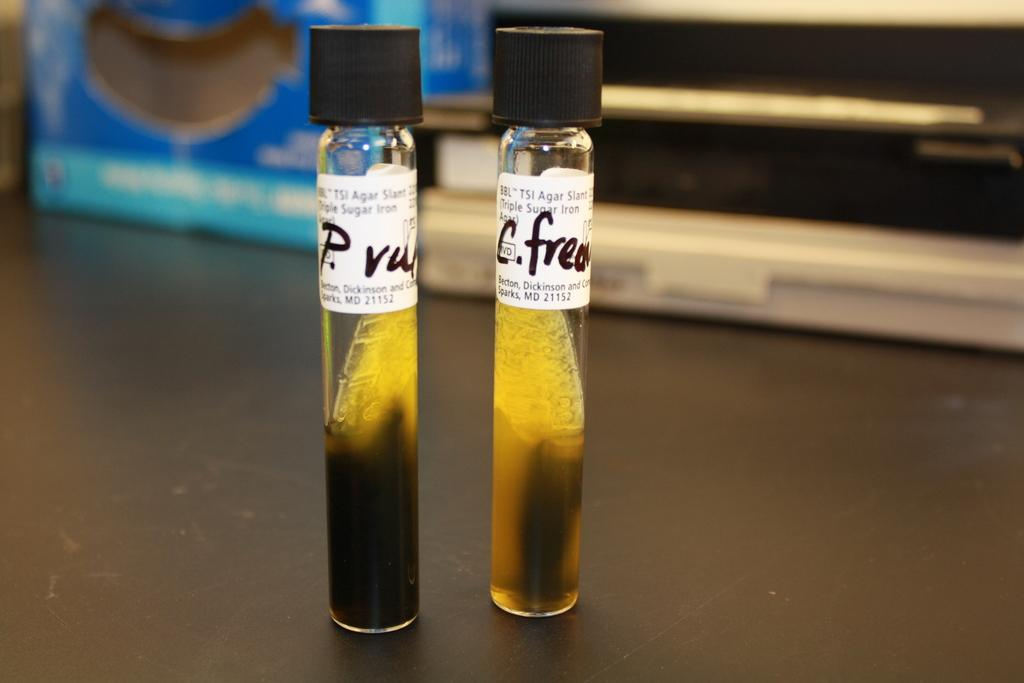<image>
Give a short and clear explanation of the subsequent image. two vials full of murky ingredients labeled TSI Agar Slant 